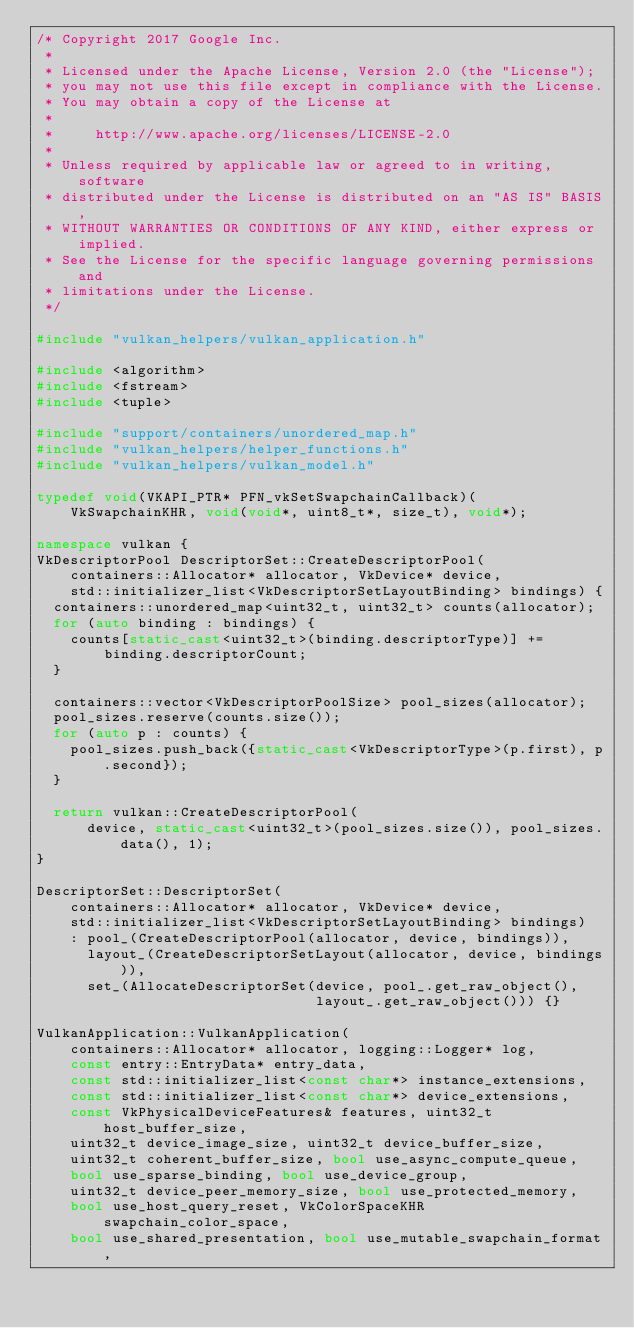Convert code to text. <code><loc_0><loc_0><loc_500><loc_500><_C++_>/* Copyright 2017 Google Inc.
 *
 * Licensed under the Apache License, Version 2.0 (the "License");
 * you may not use this file except in compliance with the License.
 * You may obtain a copy of the License at
 *
 *     http://www.apache.org/licenses/LICENSE-2.0
 *
 * Unless required by applicable law or agreed to in writing, software
 * distributed under the License is distributed on an "AS IS" BASIS,
 * WITHOUT WARRANTIES OR CONDITIONS OF ANY KIND, either express or implied.
 * See the License for the specific language governing permissions and
 * limitations under the License.
 */

#include "vulkan_helpers/vulkan_application.h"

#include <algorithm>
#include <fstream>
#include <tuple>

#include "support/containers/unordered_map.h"
#include "vulkan_helpers/helper_functions.h"
#include "vulkan_helpers/vulkan_model.h"

typedef void(VKAPI_PTR* PFN_vkSetSwapchainCallback)(
    VkSwapchainKHR, void(void*, uint8_t*, size_t), void*);

namespace vulkan {
VkDescriptorPool DescriptorSet::CreateDescriptorPool(
    containers::Allocator* allocator, VkDevice* device,
    std::initializer_list<VkDescriptorSetLayoutBinding> bindings) {
  containers::unordered_map<uint32_t, uint32_t> counts(allocator);
  for (auto binding : bindings) {
    counts[static_cast<uint32_t>(binding.descriptorType)] +=
        binding.descriptorCount;
  }

  containers::vector<VkDescriptorPoolSize> pool_sizes(allocator);
  pool_sizes.reserve(counts.size());
  for (auto p : counts) {
    pool_sizes.push_back({static_cast<VkDescriptorType>(p.first), p.second});
  }

  return vulkan::CreateDescriptorPool(
      device, static_cast<uint32_t>(pool_sizes.size()), pool_sizes.data(), 1);
}

DescriptorSet::DescriptorSet(
    containers::Allocator* allocator, VkDevice* device,
    std::initializer_list<VkDescriptorSetLayoutBinding> bindings)
    : pool_(CreateDescriptorPool(allocator, device, bindings)),
      layout_(CreateDescriptorSetLayout(allocator, device, bindings)),
      set_(AllocateDescriptorSet(device, pool_.get_raw_object(),
                                 layout_.get_raw_object())) {}

VulkanApplication::VulkanApplication(
    containers::Allocator* allocator, logging::Logger* log,
    const entry::EntryData* entry_data,
    const std::initializer_list<const char*> instance_extensions,
    const std::initializer_list<const char*> device_extensions,
    const VkPhysicalDeviceFeatures& features, uint32_t host_buffer_size,
    uint32_t device_image_size, uint32_t device_buffer_size,
    uint32_t coherent_buffer_size, bool use_async_compute_queue,
    bool use_sparse_binding, bool use_device_group,
    uint32_t device_peer_memory_size, bool use_protected_memory,
    bool use_host_query_reset, VkColorSpaceKHR swapchain_color_space,
    bool use_shared_presentation, bool use_mutable_swapchain_format,</code> 